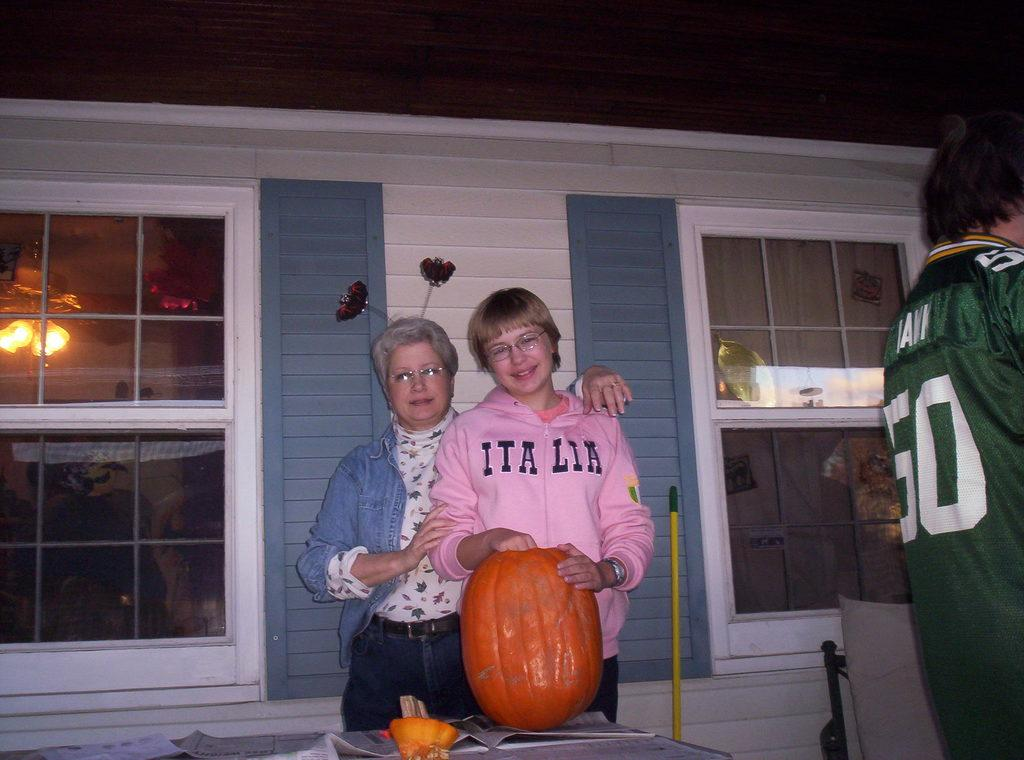<image>
Share a concise interpretation of the image provided. A girl holding a pumpking wearing a pink ITALIA sweatshirt. 